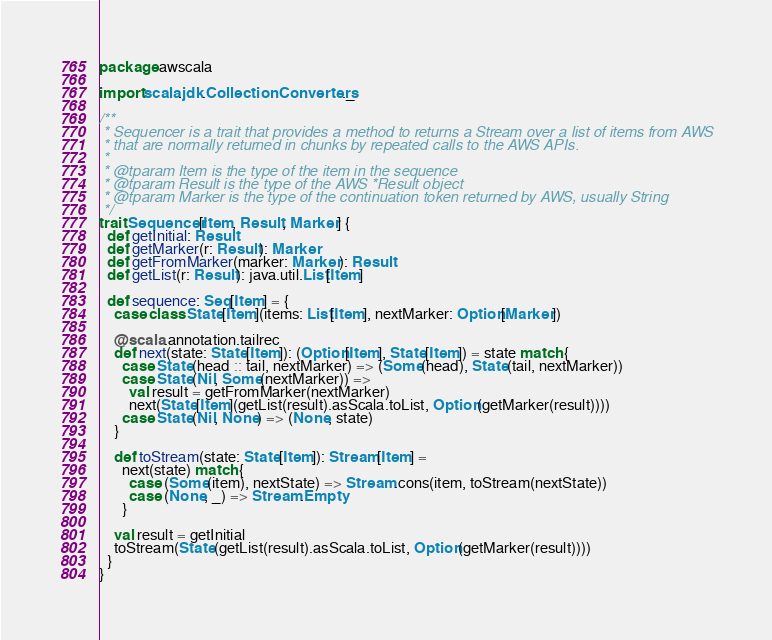Convert code to text. <code><loc_0><loc_0><loc_500><loc_500><_Scala_>package awscala

import scala.jdk.CollectionConverters._

/**
 * Sequencer is a trait that provides a method to returns a Stream over a list of items from AWS
 * that are normally returned in chunks by repeated calls to the AWS APIs.
 *
 * @tparam Item is the type of the item in the sequence
 * @tparam Result is the type of the AWS *Result object
 * @tparam Marker is the type of the continuation token returned by AWS, usually String
 */
trait Sequencer[Item, Result, Marker] {
  def getInitial: Result
  def getMarker(r: Result): Marker
  def getFromMarker(marker: Marker): Result
  def getList(r: Result): java.util.List[Item]

  def sequence: Seq[Item] = {
    case class State[Item](items: List[Item], nextMarker: Option[Marker])

    @scala.annotation.tailrec
    def next(state: State[Item]): (Option[Item], State[Item]) = state match {
      case State(head :: tail, nextMarker) => (Some(head), State(tail, nextMarker))
      case State(Nil, Some(nextMarker)) =>
        val result = getFromMarker(nextMarker)
        next(State[Item](getList(result).asScala.toList, Option(getMarker(result))))
      case State(Nil, None) => (None, state)
    }

    def toStream(state: State[Item]): Stream[Item] =
      next(state) match {
        case (Some(item), nextState) => Stream.cons(item, toStream(nextState))
        case (None, _) => Stream.Empty
      }

    val result = getInitial
    toStream(State(getList(result).asScala.toList, Option(getMarker(result))))
  }
}
</code> 